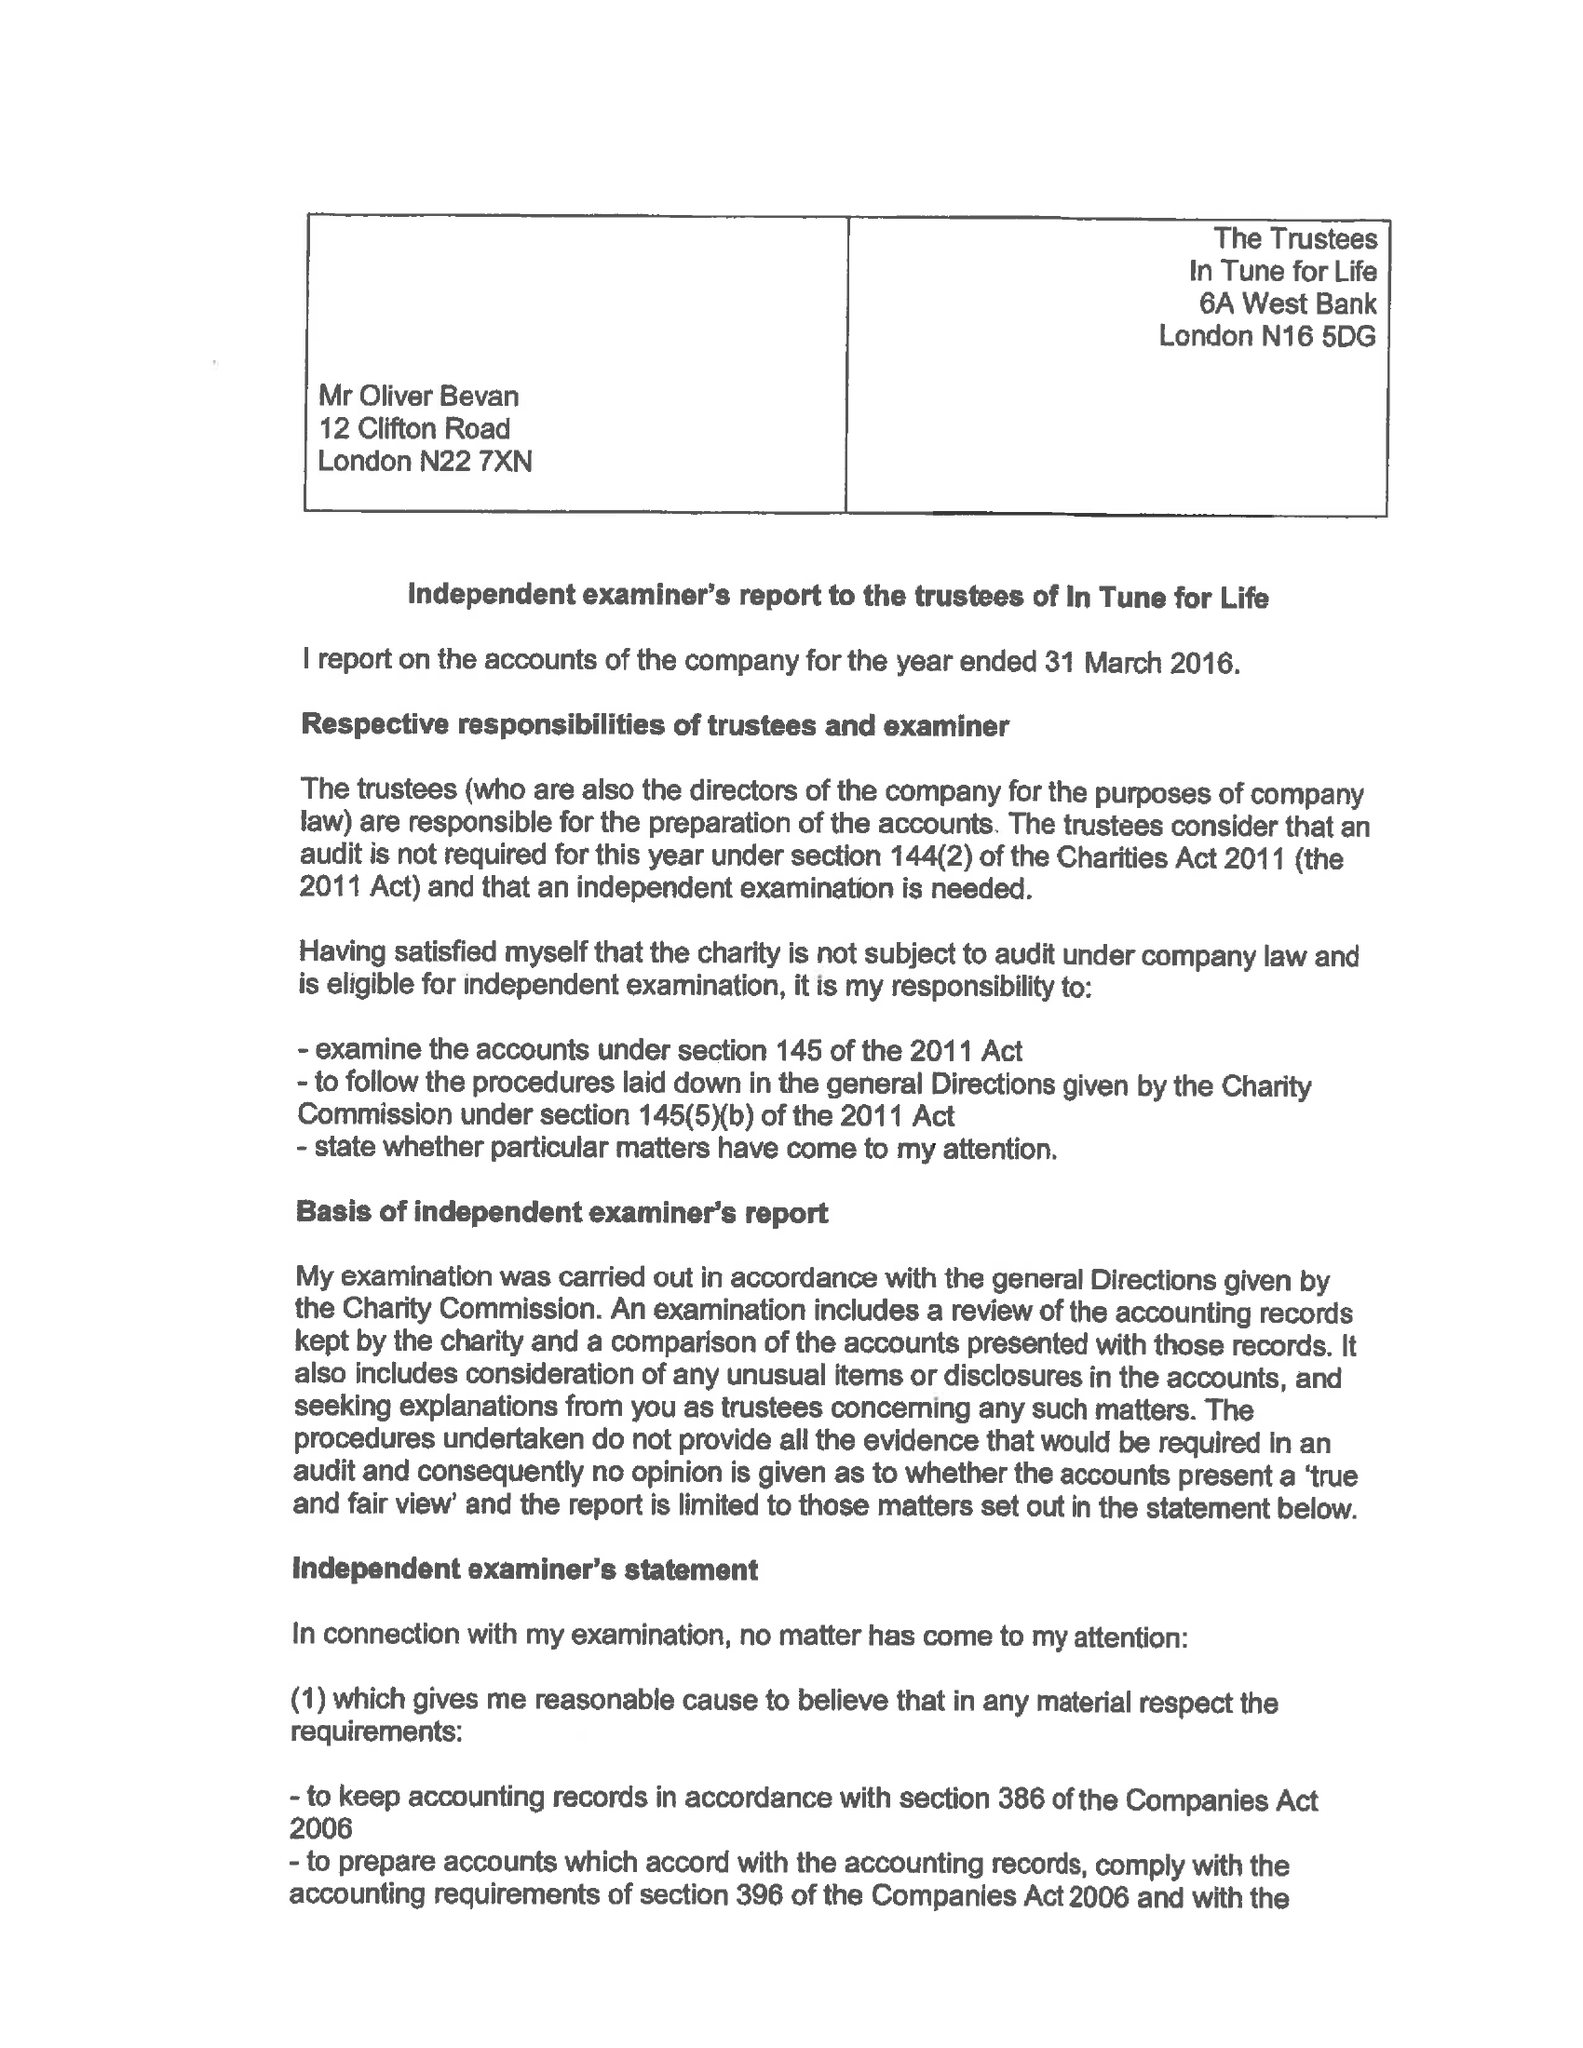What is the value for the report_date?
Answer the question using a single word or phrase. 2016-03-31 